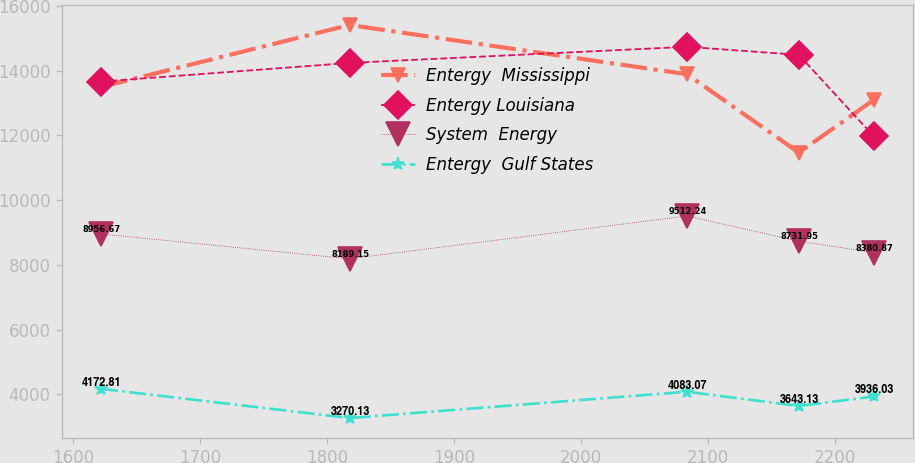<chart> <loc_0><loc_0><loc_500><loc_500><line_chart><ecel><fcel>Entergy  Mississippi<fcel>Entergy Louisiana<fcel>System  Energy<fcel>Entergy  Gulf States<nl><fcel>1621.97<fcel>13496.4<fcel>13663.2<fcel>8956.67<fcel>4172.81<nl><fcel>1817.8<fcel>15411.2<fcel>14239.1<fcel>8189.15<fcel>3270.13<nl><fcel>2083.58<fcel>13890.6<fcel>14737.1<fcel>9512.24<fcel>4083.07<nl><fcel>2171.82<fcel>11469.3<fcel>14488.1<fcel>8731.95<fcel>3643.13<nl><fcel>2230.97<fcel>13102.2<fcel>11967.8<fcel>8380.87<fcel>3936.03<nl></chart> 